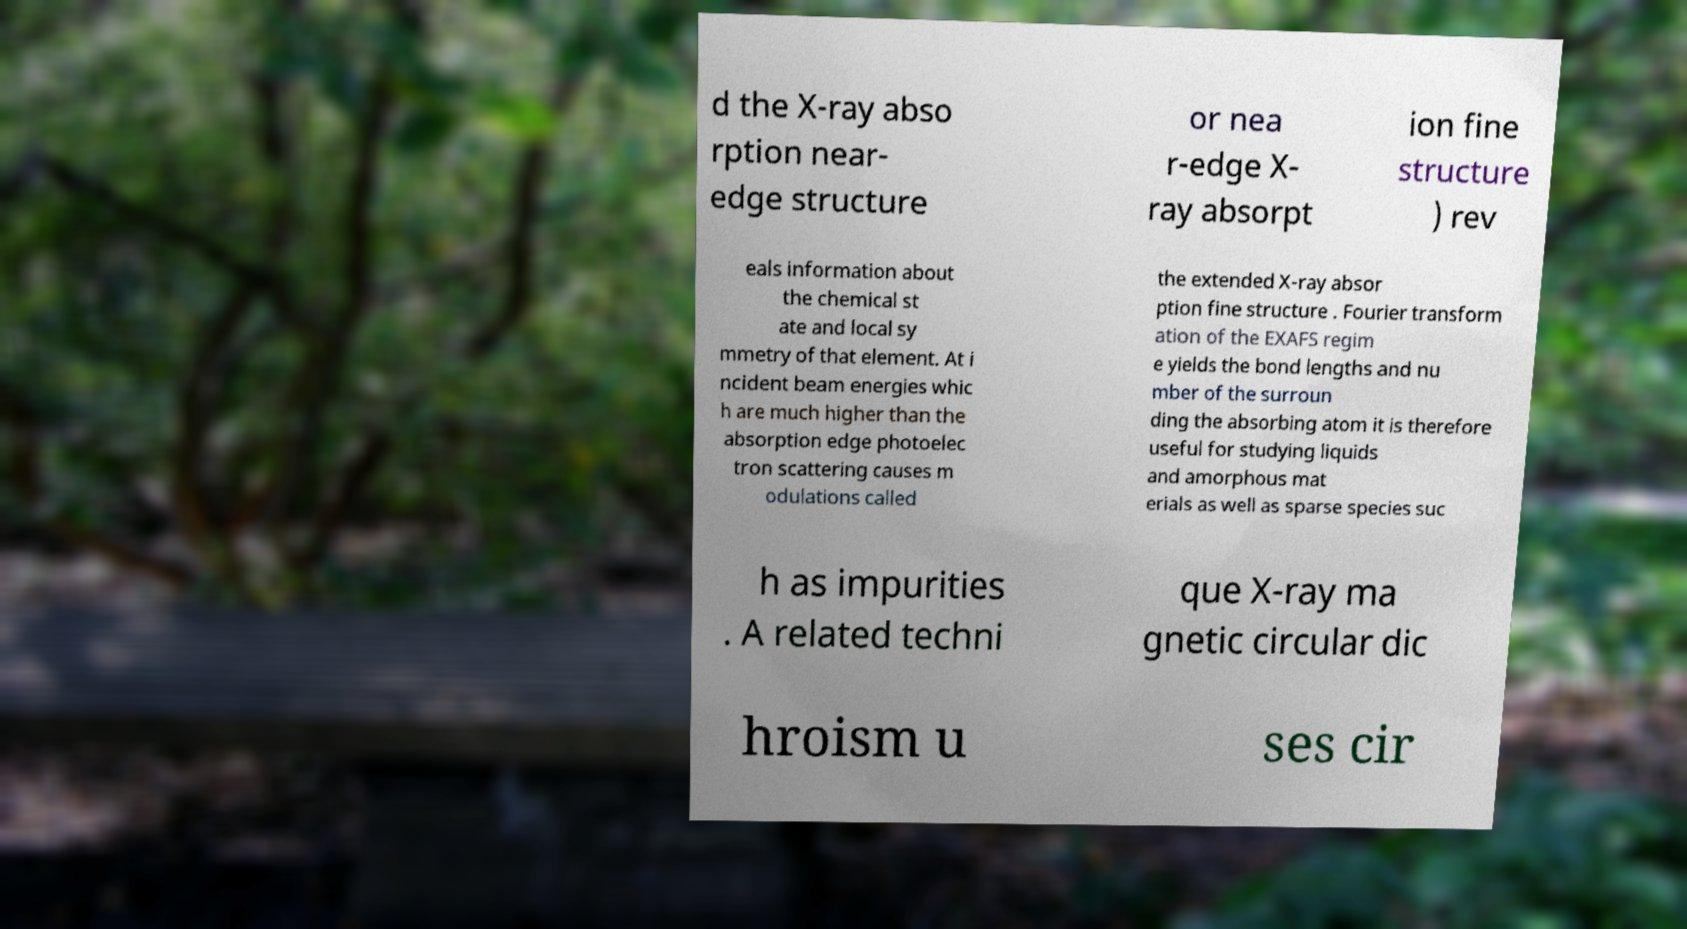There's text embedded in this image that I need extracted. Can you transcribe it verbatim? d the X-ray abso rption near- edge structure or nea r-edge X- ray absorpt ion fine structure ) rev eals information about the chemical st ate and local sy mmetry of that element. At i ncident beam energies whic h are much higher than the absorption edge photoelec tron scattering causes m odulations called the extended X-ray absor ption fine structure . Fourier transform ation of the EXAFS regim e yields the bond lengths and nu mber of the surroun ding the absorbing atom it is therefore useful for studying liquids and amorphous mat erials as well as sparse species suc h as impurities . A related techni que X-ray ma gnetic circular dic hroism u ses cir 